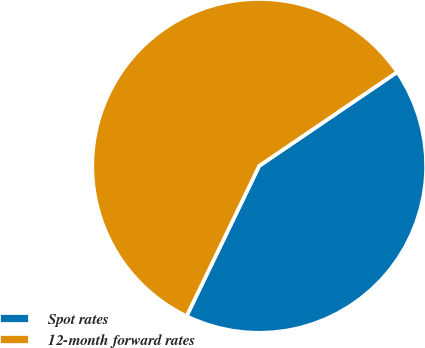Convert chart. <chart><loc_0><loc_0><loc_500><loc_500><pie_chart><fcel>Spot rates<fcel>12-month forward rates<nl><fcel>41.67%<fcel>58.33%<nl></chart> 